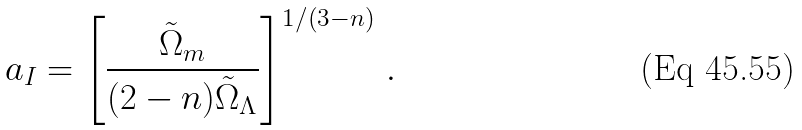Convert formula to latex. <formula><loc_0><loc_0><loc_500><loc_500>a _ { I } = \left [ \frac { \tilde { \Omega } _ { m } } { ( 2 - n ) \tilde { \Omega } _ { \Lambda } } \right ] ^ { 1 / ( 3 - n ) } \, .</formula> 